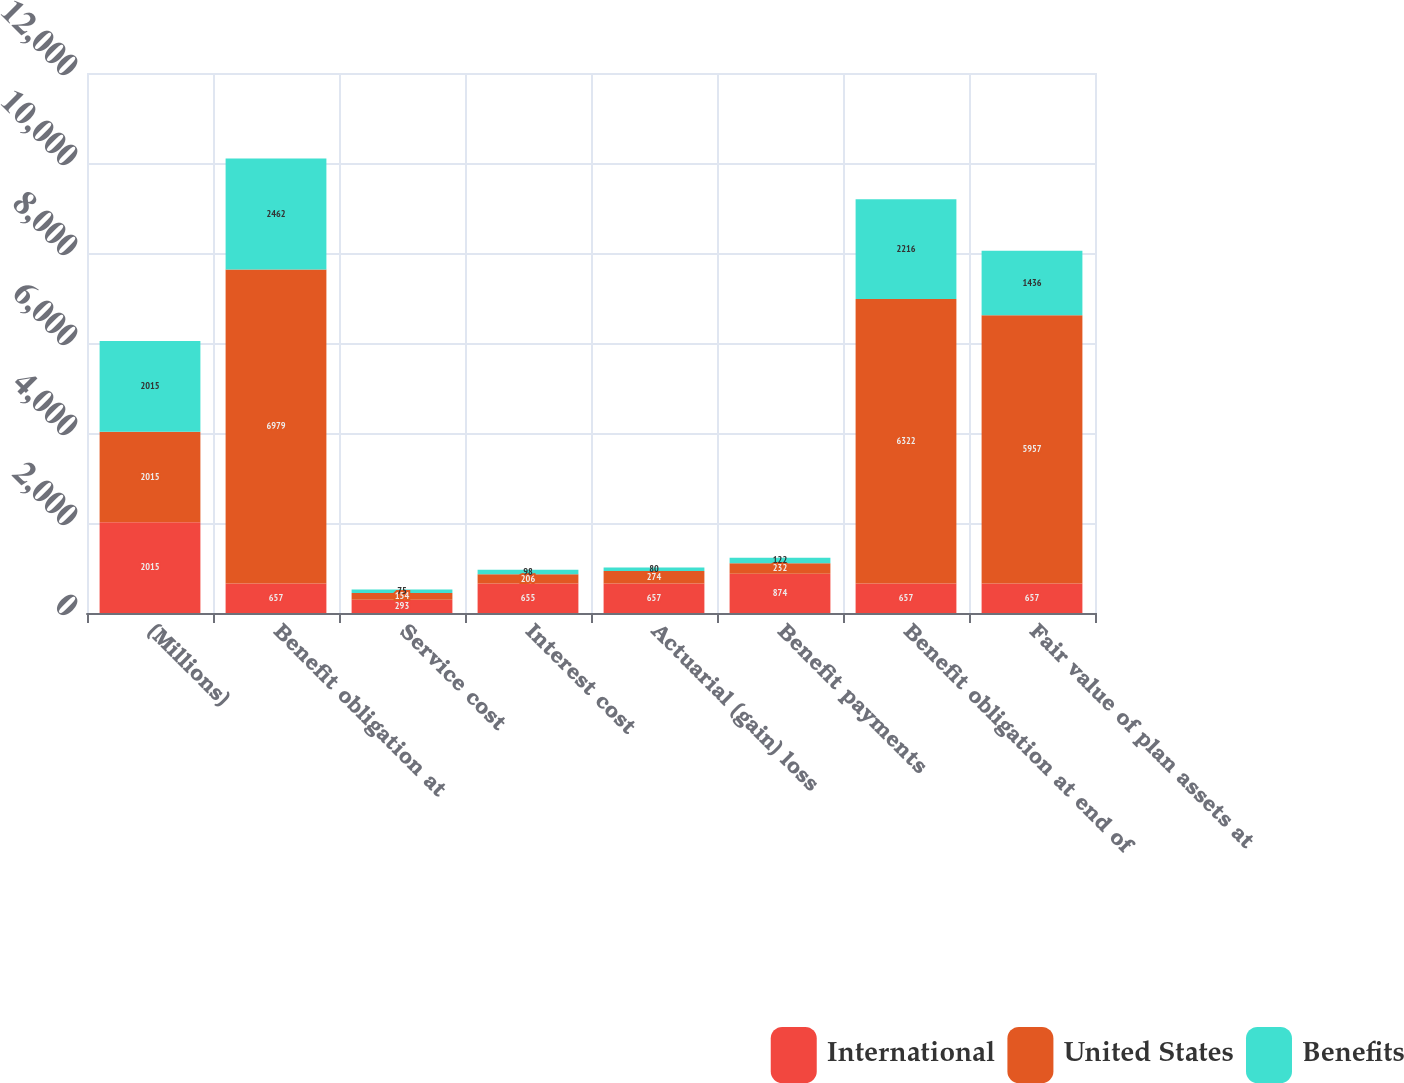Convert chart. <chart><loc_0><loc_0><loc_500><loc_500><stacked_bar_chart><ecel><fcel>(Millions)<fcel>Benefit obligation at<fcel>Service cost<fcel>Interest cost<fcel>Actuarial (gain) loss<fcel>Benefit payments<fcel>Benefit obligation at end of<fcel>Fair value of plan assets at<nl><fcel>International<fcel>2015<fcel>657<fcel>293<fcel>655<fcel>657<fcel>874<fcel>657<fcel>657<nl><fcel>United States<fcel>2015<fcel>6979<fcel>154<fcel>206<fcel>274<fcel>232<fcel>6322<fcel>5957<nl><fcel>Benefits<fcel>2015<fcel>2462<fcel>75<fcel>98<fcel>80<fcel>122<fcel>2216<fcel>1436<nl></chart> 